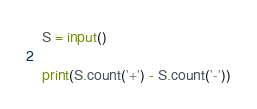Convert code to text. <code><loc_0><loc_0><loc_500><loc_500><_Python_>S = input()

print(S.count('+') - S.count('-'))
</code> 